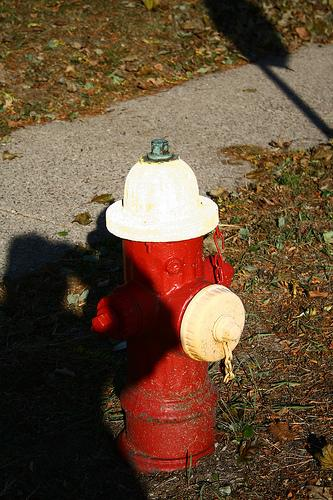What is visible on the ground around the fire hydrant? There are leaves, grass, a small rock, and a shadow behind the red hydrant on the ground. Enumerate the objects that can be found on the sidewalk. On the sidewalk, there are several leaves, a gray spotted area, and a part of a stone. Explain the color scheme and any chains on the fire hydrant. The fire hydrant has a red body and a white cap, with a red chain and a white chain hanging from it. Specify the object observed on top of the fire hydrant. A bolt is observed on top of the fire hydrant. In a detailed sentence, describe the grass growing near the fire hydrant. There is green grass growing beside the fire hydrant, with some leaves and red and brown debris on the ground. Describe the state of the sidewalk in the image. The sidewalk is gray, spotted, and it stretches behind the fire hydrant. Mention the primary object of interest and its color in the image. The primary object of interest in the image is a red and white fire hydrant. Which object can be found close to the grass growing beside the fire hydrant? Part of a stone Where is the shadow of the person taking the picture located? On the grass List three items that can be found on the ground near the fire hydrant in the image. Small rock, red and brown debris, green leaves Identify the objects present in the image forming a meaningful connection between them. A red and white fire hydrant stands on a gray sidewalk surrounded by green grass and a person's shadow, with a red chain hanging from it. Is there a shadow on the grass in the image? If yes, describe it. Yes, there is a person's shadow on the grass. What is hanging from the fire hydrant, and what color is it? A chain, red and white Describe the position of the bolt on the fire hydrant. On top of the fire hydrant What color are the leaves on the ground? Green and brown What can be seen on the ground around the red and white fire hydrant? Green grass, gray gravel path, brown leaf, red and brown debris, and a small rock Which object is at the position closest to the top-left corner of the image? A patch of leaf covered grass Create a visually engaging description of the fire hydrant and its surroundings. A vibrant red and white fire hydrant stands tall on a gray, spotted sidewalk amidst the captivating green grass with scattered leaves and a subtle shadow behind it. Where can we find a small rock in the image? By the hydrant Are there any visible emotions depicted on the faces in the image? There are no faces in the image. Identify the type of path on the ground in the image. Gray gravel path Among the choices below, which colors are present in the fire hydrant? A) Blue and yellow B) Red and white C) Green and pink Red and white Describe the grass on the ground in the image. The grass is green and has leaf-covered patches, and it is growing beside the fire hydrant. Is there a shadow of a stop sign in the image? No, there is no shadow of a stop sign in the image. 